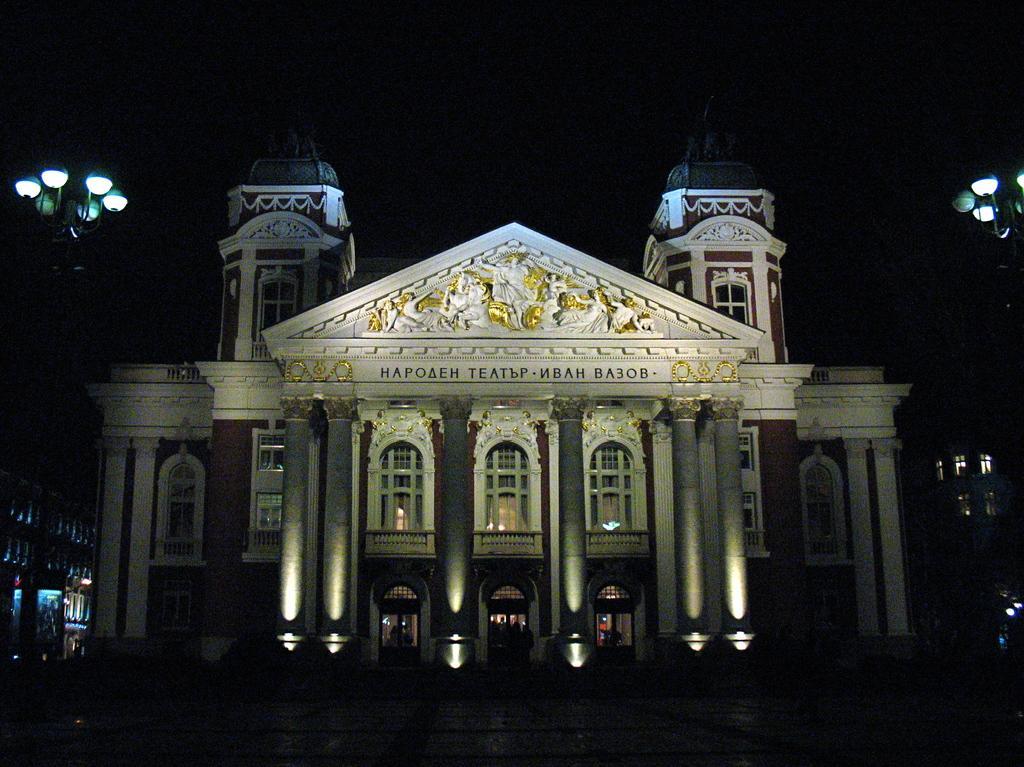Describe this image in one or two sentences. This is an image clicked in the dark. In the middle of the image there is a building along with the pillars and windows. On the right and left side of the image there are few light poles. The background is dark. 